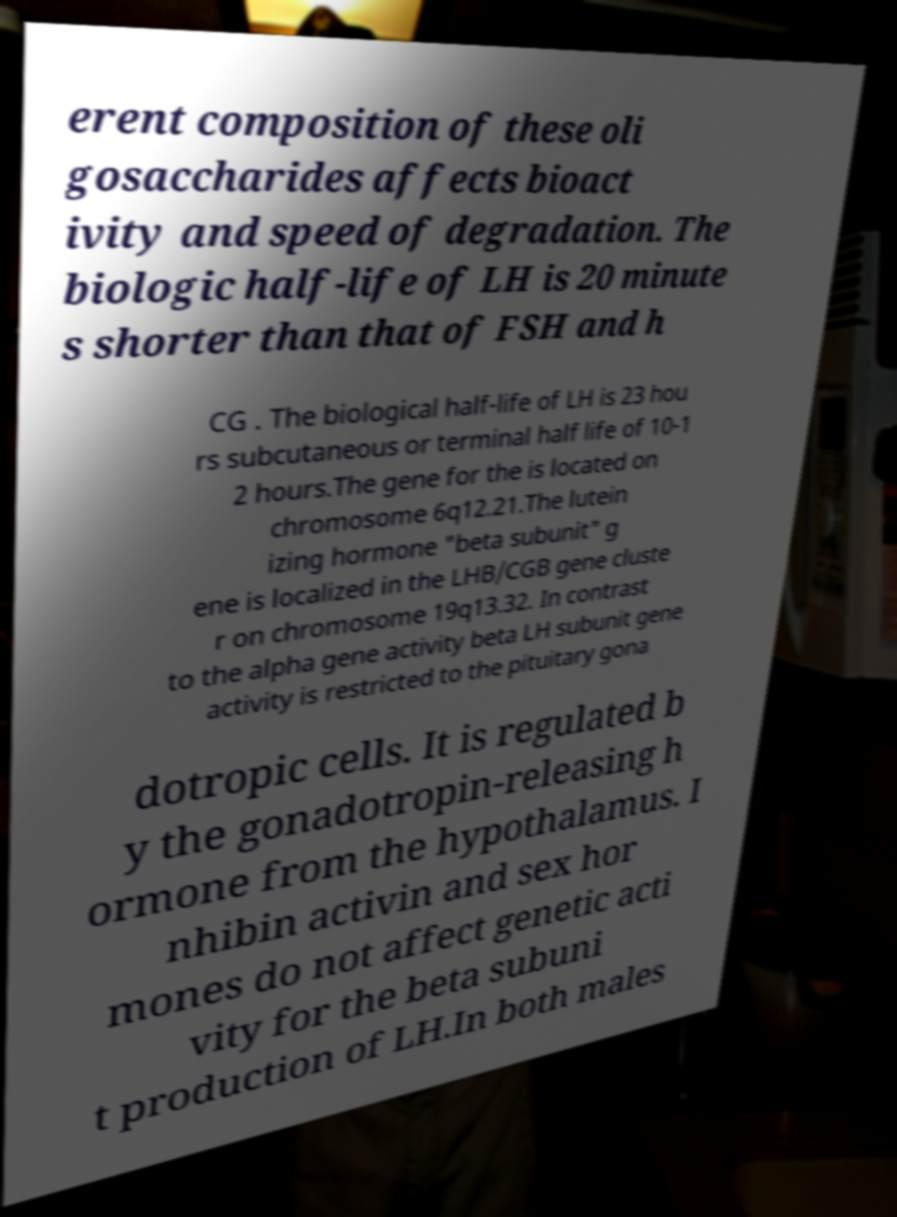Please identify and transcribe the text found in this image. erent composition of these oli gosaccharides affects bioact ivity and speed of degradation. The biologic half-life of LH is 20 minute s shorter than that of FSH and h CG . The biological half-life of LH is 23 hou rs subcutaneous or terminal half life of 10-1 2 hours.The gene for the is located on chromosome 6q12.21.The lutein izing hormone "beta subunit" g ene is localized in the LHB/CGB gene cluste r on chromosome 19q13.32. In contrast to the alpha gene activity beta LH subunit gene activity is restricted to the pituitary gona dotropic cells. It is regulated b y the gonadotropin-releasing h ormone from the hypothalamus. I nhibin activin and sex hor mones do not affect genetic acti vity for the beta subuni t production of LH.In both males 